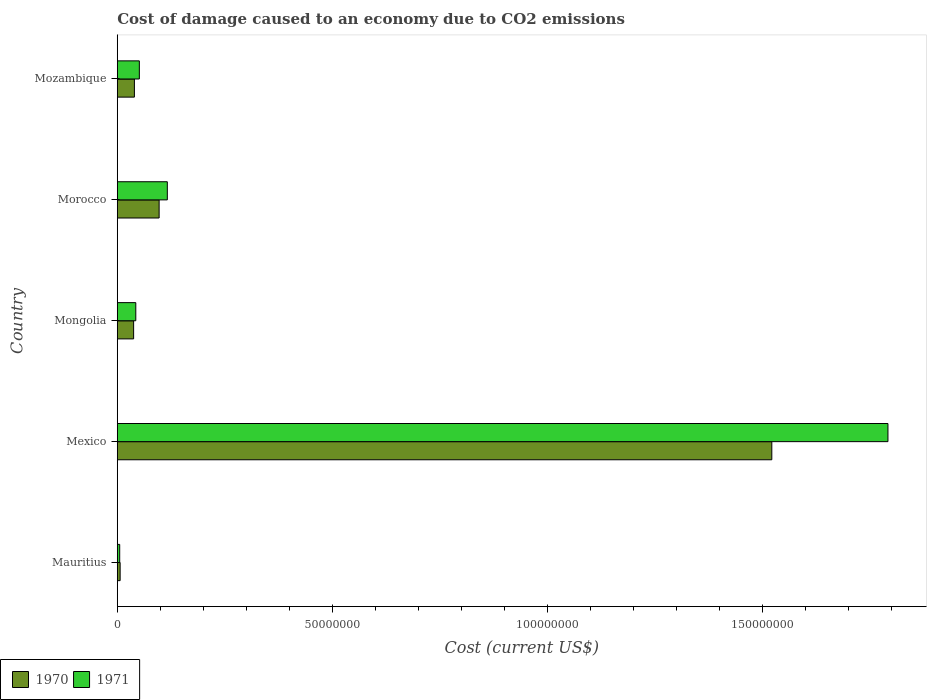How many different coloured bars are there?
Provide a succinct answer. 2. Are the number of bars per tick equal to the number of legend labels?
Give a very brief answer. Yes. How many bars are there on the 4th tick from the bottom?
Your response must be concise. 2. In how many cases, is the number of bars for a given country not equal to the number of legend labels?
Offer a terse response. 0. What is the cost of damage caused due to CO2 emissisons in 1971 in Morocco?
Make the answer very short. 1.16e+07. Across all countries, what is the maximum cost of damage caused due to CO2 emissisons in 1971?
Provide a short and direct response. 1.79e+08. Across all countries, what is the minimum cost of damage caused due to CO2 emissisons in 1971?
Give a very brief answer. 5.62e+05. In which country was the cost of damage caused due to CO2 emissisons in 1970 maximum?
Ensure brevity in your answer.  Mexico. In which country was the cost of damage caused due to CO2 emissisons in 1971 minimum?
Give a very brief answer. Mauritius. What is the total cost of damage caused due to CO2 emissisons in 1970 in the graph?
Provide a succinct answer. 1.70e+08. What is the difference between the cost of damage caused due to CO2 emissisons in 1971 in Mauritius and that in Mozambique?
Offer a very short reply. -4.57e+06. What is the difference between the cost of damage caused due to CO2 emissisons in 1970 in Morocco and the cost of damage caused due to CO2 emissisons in 1971 in Mauritius?
Keep it short and to the point. 9.17e+06. What is the average cost of damage caused due to CO2 emissisons in 1971 per country?
Give a very brief answer. 4.02e+07. What is the difference between the cost of damage caused due to CO2 emissisons in 1970 and cost of damage caused due to CO2 emissisons in 1971 in Mongolia?
Your answer should be compact. -5.05e+05. What is the ratio of the cost of damage caused due to CO2 emissisons in 1971 in Mongolia to that in Morocco?
Keep it short and to the point. 0.37. What is the difference between the highest and the second highest cost of damage caused due to CO2 emissisons in 1971?
Your answer should be compact. 1.68e+08. What is the difference between the highest and the lowest cost of damage caused due to CO2 emissisons in 1971?
Offer a terse response. 1.79e+08. Is the sum of the cost of damage caused due to CO2 emissisons in 1971 in Mexico and Mozambique greater than the maximum cost of damage caused due to CO2 emissisons in 1970 across all countries?
Offer a terse response. Yes. How many bars are there?
Offer a terse response. 10. How many countries are there in the graph?
Your response must be concise. 5. Are the values on the major ticks of X-axis written in scientific E-notation?
Your answer should be compact. No. Does the graph contain any zero values?
Make the answer very short. No. Where does the legend appear in the graph?
Give a very brief answer. Bottom left. How many legend labels are there?
Provide a short and direct response. 2. What is the title of the graph?
Your answer should be compact. Cost of damage caused to an economy due to CO2 emissions. What is the label or title of the X-axis?
Offer a very short reply. Cost (current US$). What is the Cost (current US$) of 1970 in Mauritius?
Provide a short and direct response. 6.66e+05. What is the Cost (current US$) in 1971 in Mauritius?
Your answer should be very brief. 5.62e+05. What is the Cost (current US$) of 1970 in Mexico?
Offer a very short reply. 1.52e+08. What is the Cost (current US$) in 1971 in Mexico?
Keep it short and to the point. 1.79e+08. What is the Cost (current US$) in 1970 in Mongolia?
Ensure brevity in your answer.  3.80e+06. What is the Cost (current US$) of 1971 in Mongolia?
Offer a terse response. 4.31e+06. What is the Cost (current US$) of 1970 in Morocco?
Offer a terse response. 9.74e+06. What is the Cost (current US$) of 1971 in Morocco?
Provide a short and direct response. 1.16e+07. What is the Cost (current US$) of 1970 in Mozambique?
Ensure brevity in your answer.  3.98e+06. What is the Cost (current US$) of 1971 in Mozambique?
Your response must be concise. 5.13e+06. Across all countries, what is the maximum Cost (current US$) of 1970?
Your answer should be very brief. 1.52e+08. Across all countries, what is the maximum Cost (current US$) in 1971?
Offer a terse response. 1.79e+08. Across all countries, what is the minimum Cost (current US$) in 1970?
Give a very brief answer. 6.66e+05. Across all countries, what is the minimum Cost (current US$) in 1971?
Provide a succinct answer. 5.62e+05. What is the total Cost (current US$) in 1970 in the graph?
Ensure brevity in your answer.  1.70e+08. What is the total Cost (current US$) of 1971 in the graph?
Your answer should be compact. 2.01e+08. What is the difference between the Cost (current US$) of 1970 in Mauritius and that in Mexico?
Ensure brevity in your answer.  -1.52e+08. What is the difference between the Cost (current US$) in 1971 in Mauritius and that in Mexico?
Keep it short and to the point. -1.79e+08. What is the difference between the Cost (current US$) in 1970 in Mauritius and that in Mongolia?
Give a very brief answer. -3.14e+06. What is the difference between the Cost (current US$) of 1971 in Mauritius and that in Mongolia?
Ensure brevity in your answer.  -3.75e+06. What is the difference between the Cost (current US$) in 1970 in Mauritius and that in Morocco?
Offer a very short reply. -9.07e+06. What is the difference between the Cost (current US$) of 1971 in Mauritius and that in Morocco?
Provide a short and direct response. -1.11e+07. What is the difference between the Cost (current US$) in 1970 in Mauritius and that in Mozambique?
Ensure brevity in your answer.  -3.32e+06. What is the difference between the Cost (current US$) in 1971 in Mauritius and that in Mozambique?
Provide a short and direct response. -4.57e+06. What is the difference between the Cost (current US$) of 1970 in Mexico and that in Mongolia?
Your answer should be compact. 1.48e+08. What is the difference between the Cost (current US$) in 1971 in Mexico and that in Mongolia?
Keep it short and to the point. 1.75e+08. What is the difference between the Cost (current US$) of 1970 in Mexico and that in Morocco?
Offer a terse response. 1.43e+08. What is the difference between the Cost (current US$) in 1971 in Mexico and that in Morocco?
Give a very brief answer. 1.68e+08. What is the difference between the Cost (current US$) in 1970 in Mexico and that in Mozambique?
Give a very brief answer. 1.48e+08. What is the difference between the Cost (current US$) of 1971 in Mexico and that in Mozambique?
Provide a short and direct response. 1.74e+08. What is the difference between the Cost (current US$) of 1970 in Mongolia and that in Morocco?
Provide a succinct answer. -5.93e+06. What is the difference between the Cost (current US$) in 1971 in Mongolia and that in Morocco?
Make the answer very short. -7.33e+06. What is the difference between the Cost (current US$) in 1970 in Mongolia and that in Mozambique?
Provide a succinct answer. -1.81e+05. What is the difference between the Cost (current US$) in 1971 in Mongolia and that in Mozambique?
Provide a succinct answer. -8.22e+05. What is the difference between the Cost (current US$) of 1970 in Morocco and that in Mozambique?
Keep it short and to the point. 5.75e+06. What is the difference between the Cost (current US$) of 1971 in Morocco and that in Mozambique?
Offer a very short reply. 6.51e+06. What is the difference between the Cost (current US$) of 1970 in Mauritius and the Cost (current US$) of 1971 in Mexico?
Provide a succinct answer. -1.79e+08. What is the difference between the Cost (current US$) in 1970 in Mauritius and the Cost (current US$) in 1971 in Mongolia?
Keep it short and to the point. -3.64e+06. What is the difference between the Cost (current US$) of 1970 in Mauritius and the Cost (current US$) of 1971 in Morocco?
Your answer should be compact. -1.10e+07. What is the difference between the Cost (current US$) in 1970 in Mauritius and the Cost (current US$) in 1971 in Mozambique?
Keep it short and to the point. -4.47e+06. What is the difference between the Cost (current US$) of 1970 in Mexico and the Cost (current US$) of 1971 in Mongolia?
Make the answer very short. 1.48e+08. What is the difference between the Cost (current US$) in 1970 in Mexico and the Cost (current US$) in 1971 in Morocco?
Provide a short and direct response. 1.41e+08. What is the difference between the Cost (current US$) of 1970 in Mexico and the Cost (current US$) of 1971 in Mozambique?
Keep it short and to the point. 1.47e+08. What is the difference between the Cost (current US$) of 1970 in Mongolia and the Cost (current US$) of 1971 in Morocco?
Provide a short and direct response. -7.84e+06. What is the difference between the Cost (current US$) in 1970 in Mongolia and the Cost (current US$) in 1971 in Mozambique?
Give a very brief answer. -1.33e+06. What is the difference between the Cost (current US$) in 1970 in Morocco and the Cost (current US$) in 1971 in Mozambique?
Make the answer very short. 4.60e+06. What is the average Cost (current US$) of 1970 per country?
Offer a terse response. 3.41e+07. What is the average Cost (current US$) in 1971 per country?
Provide a short and direct response. 4.02e+07. What is the difference between the Cost (current US$) of 1970 and Cost (current US$) of 1971 in Mauritius?
Your response must be concise. 1.04e+05. What is the difference between the Cost (current US$) of 1970 and Cost (current US$) of 1971 in Mexico?
Provide a short and direct response. -2.70e+07. What is the difference between the Cost (current US$) of 1970 and Cost (current US$) of 1971 in Mongolia?
Give a very brief answer. -5.05e+05. What is the difference between the Cost (current US$) in 1970 and Cost (current US$) in 1971 in Morocco?
Provide a succinct answer. -1.91e+06. What is the difference between the Cost (current US$) in 1970 and Cost (current US$) in 1971 in Mozambique?
Provide a short and direct response. -1.15e+06. What is the ratio of the Cost (current US$) in 1970 in Mauritius to that in Mexico?
Keep it short and to the point. 0. What is the ratio of the Cost (current US$) in 1971 in Mauritius to that in Mexico?
Your response must be concise. 0. What is the ratio of the Cost (current US$) in 1970 in Mauritius to that in Mongolia?
Offer a very short reply. 0.17. What is the ratio of the Cost (current US$) of 1971 in Mauritius to that in Mongolia?
Your answer should be very brief. 0.13. What is the ratio of the Cost (current US$) of 1970 in Mauritius to that in Morocco?
Ensure brevity in your answer.  0.07. What is the ratio of the Cost (current US$) in 1971 in Mauritius to that in Morocco?
Provide a succinct answer. 0.05. What is the ratio of the Cost (current US$) of 1970 in Mauritius to that in Mozambique?
Your answer should be compact. 0.17. What is the ratio of the Cost (current US$) of 1971 in Mauritius to that in Mozambique?
Provide a short and direct response. 0.11. What is the ratio of the Cost (current US$) in 1970 in Mexico to that in Mongolia?
Provide a short and direct response. 40.04. What is the ratio of the Cost (current US$) in 1971 in Mexico to that in Mongolia?
Your answer should be very brief. 41.61. What is the ratio of the Cost (current US$) in 1970 in Mexico to that in Morocco?
Ensure brevity in your answer.  15.64. What is the ratio of the Cost (current US$) of 1971 in Mexico to that in Morocco?
Provide a succinct answer. 15.4. What is the ratio of the Cost (current US$) in 1970 in Mexico to that in Mozambique?
Your answer should be very brief. 38.22. What is the ratio of the Cost (current US$) in 1971 in Mexico to that in Mozambique?
Keep it short and to the point. 34.94. What is the ratio of the Cost (current US$) of 1970 in Mongolia to that in Morocco?
Ensure brevity in your answer.  0.39. What is the ratio of the Cost (current US$) of 1971 in Mongolia to that in Morocco?
Keep it short and to the point. 0.37. What is the ratio of the Cost (current US$) of 1970 in Mongolia to that in Mozambique?
Provide a short and direct response. 0.95. What is the ratio of the Cost (current US$) in 1971 in Mongolia to that in Mozambique?
Keep it short and to the point. 0.84. What is the ratio of the Cost (current US$) of 1970 in Morocco to that in Mozambique?
Offer a very short reply. 2.44. What is the ratio of the Cost (current US$) of 1971 in Morocco to that in Mozambique?
Your answer should be very brief. 2.27. What is the difference between the highest and the second highest Cost (current US$) in 1970?
Offer a very short reply. 1.43e+08. What is the difference between the highest and the second highest Cost (current US$) of 1971?
Your response must be concise. 1.68e+08. What is the difference between the highest and the lowest Cost (current US$) of 1970?
Your answer should be very brief. 1.52e+08. What is the difference between the highest and the lowest Cost (current US$) in 1971?
Offer a terse response. 1.79e+08. 